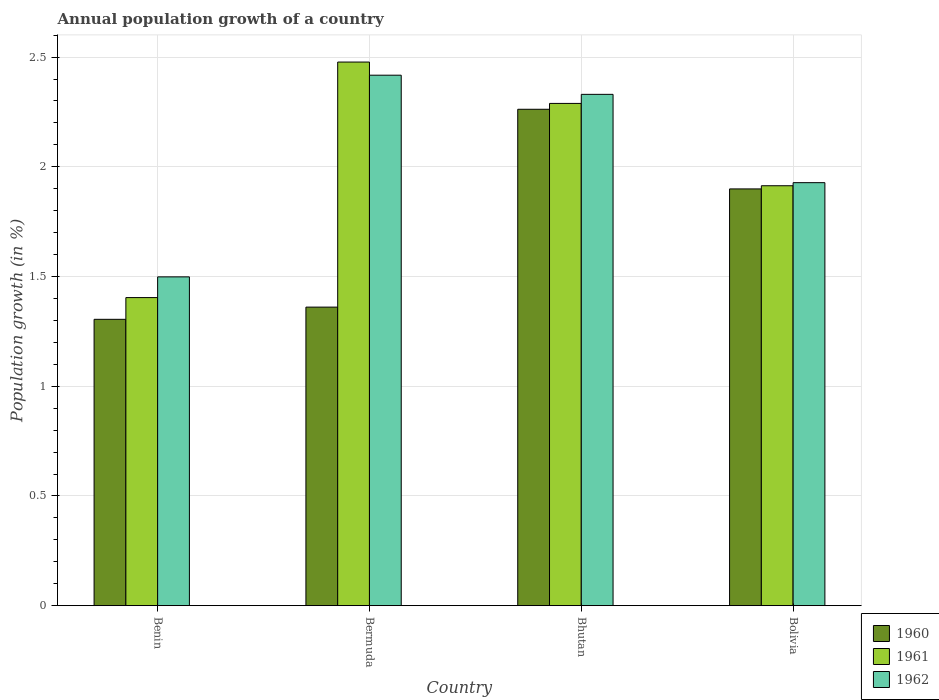How many bars are there on the 1st tick from the right?
Your answer should be compact. 3. What is the label of the 2nd group of bars from the left?
Ensure brevity in your answer.  Bermuda. What is the annual population growth in 1962 in Bermuda?
Offer a very short reply. 2.42. Across all countries, what is the maximum annual population growth in 1960?
Provide a short and direct response. 2.26. Across all countries, what is the minimum annual population growth in 1961?
Your response must be concise. 1.4. In which country was the annual population growth in 1960 maximum?
Make the answer very short. Bhutan. In which country was the annual population growth in 1962 minimum?
Your response must be concise. Benin. What is the total annual population growth in 1960 in the graph?
Your response must be concise. 6.83. What is the difference between the annual population growth in 1961 in Bhutan and that in Bolivia?
Your answer should be compact. 0.38. What is the difference between the annual population growth in 1960 in Bolivia and the annual population growth in 1962 in Benin?
Give a very brief answer. 0.4. What is the average annual population growth in 1960 per country?
Ensure brevity in your answer.  1.71. What is the difference between the annual population growth of/in 1961 and annual population growth of/in 1962 in Benin?
Provide a succinct answer. -0.09. In how many countries, is the annual population growth in 1961 greater than 0.30000000000000004 %?
Ensure brevity in your answer.  4. What is the ratio of the annual population growth in 1960 in Benin to that in Bhutan?
Offer a terse response. 0.58. Is the difference between the annual population growth in 1961 in Bhutan and Bolivia greater than the difference between the annual population growth in 1962 in Bhutan and Bolivia?
Provide a short and direct response. No. What is the difference between the highest and the second highest annual population growth in 1960?
Make the answer very short. -0.36. What is the difference between the highest and the lowest annual population growth in 1961?
Provide a succinct answer. 1.07. In how many countries, is the annual population growth in 1962 greater than the average annual population growth in 1962 taken over all countries?
Provide a short and direct response. 2. Is the sum of the annual population growth in 1962 in Benin and Bermuda greater than the maximum annual population growth in 1961 across all countries?
Keep it short and to the point. Yes. What does the 3rd bar from the left in Bhutan represents?
Provide a short and direct response. 1962. Is it the case that in every country, the sum of the annual population growth in 1961 and annual population growth in 1960 is greater than the annual population growth in 1962?
Keep it short and to the point. Yes. How many bars are there?
Your answer should be very brief. 12. Are the values on the major ticks of Y-axis written in scientific E-notation?
Give a very brief answer. No. Does the graph contain any zero values?
Your response must be concise. No. Does the graph contain grids?
Give a very brief answer. Yes. Where does the legend appear in the graph?
Offer a very short reply. Bottom right. How are the legend labels stacked?
Your answer should be very brief. Vertical. What is the title of the graph?
Give a very brief answer. Annual population growth of a country. What is the label or title of the X-axis?
Your response must be concise. Country. What is the label or title of the Y-axis?
Provide a succinct answer. Population growth (in %). What is the Population growth (in %) of 1960 in Benin?
Give a very brief answer. 1.3. What is the Population growth (in %) in 1961 in Benin?
Your answer should be compact. 1.4. What is the Population growth (in %) in 1962 in Benin?
Provide a short and direct response. 1.5. What is the Population growth (in %) in 1960 in Bermuda?
Ensure brevity in your answer.  1.36. What is the Population growth (in %) in 1961 in Bermuda?
Your answer should be compact. 2.48. What is the Population growth (in %) of 1962 in Bermuda?
Make the answer very short. 2.42. What is the Population growth (in %) of 1960 in Bhutan?
Offer a terse response. 2.26. What is the Population growth (in %) in 1961 in Bhutan?
Make the answer very short. 2.29. What is the Population growth (in %) of 1962 in Bhutan?
Make the answer very short. 2.33. What is the Population growth (in %) in 1960 in Bolivia?
Your answer should be compact. 1.9. What is the Population growth (in %) in 1961 in Bolivia?
Provide a short and direct response. 1.91. What is the Population growth (in %) of 1962 in Bolivia?
Keep it short and to the point. 1.93. Across all countries, what is the maximum Population growth (in %) in 1960?
Ensure brevity in your answer.  2.26. Across all countries, what is the maximum Population growth (in %) of 1961?
Make the answer very short. 2.48. Across all countries, what is the maximum Population growth (in %) of 1962?
Provide a succinct answer. 2.42. Across all countries, what is the minimum Population growth (in %) of 1960?
Your answer should be very brief. 1.3. Across all countries, what is the minimum Population growth (in %) in 1961?
Give a very brief answer. 1.4. Across all countries, what is the minimum Population growth (in %) of 1962?
Ensure brevity in your answer.  1.5. What is the total Population growth (in %) of 1960 in the graph?
Give a very brief answer. 6.83. What is the total Population growth (in %) of 1961 in the graph?
Provide a short and direct response. 8.08. What is the total Population growth (in %) of 1962 in the graph?
Your response must be concise. 8.17. What is the difference between the Population growth (in %) in 1960 in Benin and that in Bermuda?
Make the answer very short. -0.06. What is the difference between the Population growth (in %) of 1961 in Benin and that in Bermuda?
Provide a short and direct response. -1.07. What is the difference between the Population growth (in %) of 1962 in Benin and that in Bermuda?
Offer a terse response. -0.92. What is the difference between the Population growth (in %) of 1960 in Benin and that in Bhutan?
Your answer should be very brief. -0.96. What is the difference between the Population growth (in %) of 1961 in Benin and that in Bhutan?
Give a very brief answer. -0.89. What is the difference between the Population growth (in %) of 1962 in Benin and that in Bhutan?
Your answer should be compact. -0.83. What is the difference between the Population growth (in %) of 1960 in Benin and that in Bolivia?
Provide a succinct answer. -0.59. What is the difference between the Population growth (in %) in 1961 in Benin and that in Bolivia?
Keep it short and to the point. -0.51. What is the difference between the Population growth (in %) in 1962 in Benin and that in Bolivia?
Offer a very short reply. -0.43. What is the difference between the Population growth (in %) of 1960 in Bermuda and that in Bhutan?
Ensure brevity in your answer.  -0.9. What is the difference between the Population growth (in %) in 1961 in Bermuda and that in Bhutan?
Provide a succinct answer. 0.19. What is the difference between the Population growth (in %) in 1962 in Bermuda and that in Bhutan?
Offer a terse response. 0.09. What is the difference between the Population growth (in %) of 1960 in Bermuda and that in Bolivia?
Your answer should be compact. -0.54. What is the difference between the Population growth (in %) of 1961 in Bermuda and that in Bolivia?
Give a very brief answer. 0.56. What is the difference between the Population growth (in %) in 1962 in Bermuda and that in Bolivia?
Offer a terse response. 0.49. What is the difference between the Population growth (in %) in 1960 in Bhutan and that in Bolivia?
Offer a very short reply. 0.36. What is the difference between the Population growth (in %) of 1961 in Bhutan and that in Bolivia?
Make the answer very short. 0.38. What is the difference between the Population growth (in %) in 1962 in Bhutan and that in Bolivia?
Your answer should be compact. 0.4. What is the difference between the Population growth (in %) in 1960 in Benin and the Population growth (in %) in 1961 in Bermuda?
Your answer should be very brief. -1.17. What is the difference between the Population growth (in %) of 1960 in Benin and the Population growth (in %) of 1962 in Bermuda?
Your response must be concise. -1.11. What is the difference between the Population growth (in %) in 1961 in Benin and the Population growth (in %) in 1962 in Bermuda?
Your answer should be very brief. -1.01. What is the difference between the Population growth (in %) of 1960 in Benin and the Population growth (in %) of 1961 in Bhutan?
Your answer should be compact. -0.98. What is the difference between the Population growth (in %) of 1960 in Benin and the Population growth (in %) of 1962 in Bhutan?
Your answer should be compact. -1.03. What is the difference between the Population growth (in %) in 1961 in Benin and the Population growth (in %) in 1962 in Bhutan?
Ensure brevity in your answer.  -0.93. What is the difference between the Population growth (in %) of 1960 in Benin and the Population growth (in %) of 1961 in Bolivia?
Your answer should be compact. -0.61. What is the difference between the Population growth (in %) of 1960 in Benin and the Population growth (in %) of 1962 in Bolivia?
Ensure brevity in your answer.  -0.62. What is the difference between the Population growth (in %) of 1961 in Benin and the Population growth (in %) of 1962 in Bolivia?
Your answer should be compact. -0.52. What is the difference between the Population growth (in %) in 1960 in Bermuda and the Population growth (in %) in 1961 in Bhutan?
Offer a very short reply. -0.93. What is the difference between the Population growth (in %) of 1960 in Bermuda and the Population growth (in %) of 1962 in Bhutan?
Make the answer very short. -0.97. What is the difference between the Population growth (in %) in 1961 in Bermuda and the Population growth (in %) in 1962 in Bhutan?
Your response must be concise. 0.15. What is the difference between the Population growth (in %) in 1960 in Bermuda and the Population growth (in %) in 1961 in Bolivia?
Make the answer very short. -0.55. What is the difference between the Population growth (in %) of 1960 in Bermuda and the Population growth (in %) of 1962 in Bolivia?
Offer a very short reply. -0.57. What is the difference between the Population growth (in %) in 1961 in Bermuda and the Population growth (in %) in 1962 in Bolivia?
Provide a succinct answer. 0.55. What is the difference between the Population growth (in %) of 1960 in Bhutan and the Population growth (in %) of 1961 in Bolivia?
Your answer should be very brief. 0.35. What is the difference between the Population growth (in %) in 1960 in Bhutan and the Population growth (in %) in 1962 in Bolivia?
Offer a very short reply. 0.33. What is the difference between the Population growth (in %) of 1961 in Bhutan and the Population growth (in %) of 1962 in Bolivia?
Your answer should be compact. 0.36. What is the average Population growth (in %) in 1960 per country?
Provide a succinct answer. 1.71. What is the average Population growth (in %) of 1961 per country?
Your answer should be very brief. 2.02. What is the average Population growth (in %) of 1962 per country?
Make the answer very short. 2.04. What is the difference between the Population growth (in %) of 1960 and Population growth (in %) of 1961 in Benin?
Your response must be concise. -0.1. What is the difference between the Population growth (in %) of 1960 and Population growth (in %) of 1962 in Benin?
Provide a succinct answer. -0.19. What is the difference between the Population growth (in %) in 1961 and Population growth (in %) in 1962 in Benin?
Your answer should be compact. -0.09. What is the difference between the Population growth (in %) in 1960 and Population growth (in %) in 1961 in Bermuda?
Provide a short and direct response. -1.12. What is the difference between the Population growth (in %) in 1960 and Population growth (in %) in 1962 in Bermuda?
Keep it short and to the point. -1.06. What is the difference between the Population growth (in %) of 1961 and Population growth (in %) of 1962 in Bermuda?
Your response must be concise. 0.06. What is the difference between the Population growth (in %) of 1960 and Population growth (in %) of 1961 in Bhutan?
Ensure brevity in your answer.  -0.03. What is the difference between the Population growth (in %) in 1960 and Population growth (in %) in 1962 in Bhutan?
Make the answer very short. -0.07. What is the difference between the Population growth (in %) in 1961 and Population growth (in %) in 1962 in Bhutan?
Make the answer very short. -0.04. What is the difference between the Population growth (in %) of 1960 and Population growth (in %) of 1961 in Bolivia?
Keep it short and to the point. -0.01. What is the difference between the Population growth (in %) of 1960 and Population growth (in %) of 1962 in Bolivia?
Keep it short and to the point. -0.03. What is the difference between the Population growth (in %) of 1961 and Population growth (in %) of 1962 in Bolivia?
Give a very brief answer. -0.01. What is the ratio of the Population growth (in %) of 1960 in Benin to that in Bermuda?
Keep it short and to the point. 0.96. What is the ratio of the Population growth (in %) in 1961 in Benin to that in Bermuda?
Provide a short and direct response. 0.57. What is the ratio of the Population growth (in %) of 1962 in Benin to that in Bermuda?
Provide a short and direct response. 0.62. What is the ratio of the Population growth (in %) of 1960 in Benin to that in Bhutan?
Your response must be concise. 0.58. What is the ratio of the Population growth (in %) of 1961 in Benin to that in Bhutan?
Your answer should be compact. 0.61. What is the ratio of the Population growth (in %) of 1962 in Benin to that in Bhutan?
Your answer should be compact. 0.64. What is the ratio of the Population growth (in %) of 1960 in Benin to that in Bolivia?
Keep it short and to the point. 0.69. What is the ratio of the Population growth (in %) in 1961 in Benin to that in Bolivia?
Keep it short and to the point. 0.73. What is the ratio of the Population growth (in %) of 1962 in Benin to that in Bolivia?
Make the answer very short. 0.78. What is the ratio of the Population growth (in %) in 1960 in Bermuda to that in Bhutan?
Your answer should be compact. 0.6. What is the ratio of the Population growth (in %) in 1961 in Bermuda to that in Bhutan?
Offer a terse response. 1.08. What is the ratio of the Population growth (in %) in 1962 in Bermuda to that in Bhutan?
Your answer should be compact. 1.04. What is the ratio of the Population growth (in %) of 1960 in Bermuda to that in Bolivia?
Provide a short and direct response. 0.72. What is the ratio of the Population growth (in %) of 1961 in Bermuda to that in Bolivia?
Give a very brief answer. 1.29. What is the ratio of the Population growth (in %) in 1962 in Bermuda to that in Bolivia?
Offer a very short reply. 1.25. What is the ratio of the Population growth (in %) in 1960 in Bhutan to that in Bolivia?
Your answer should be compact. 1.19. What is the ratio of the Population growth (in %) of 1961 in Bhutan to that in Bolivia?
Keep it short and to the point. 1.2. What is the ratio of the Population growth (in %) in 1962 in Bhutan to that in Bolivia?
Give a very brief answer. 1.21. What is the difference between the highest and the second highest Population growth (in %) of 1960?
Your answer should be very brief. 0.36. What is the difference between the highest and the second highest Population growth (in %) of 1961?
Your response must be concise. 0.19. What is the difference between the highest and the second highest Population growth (in %) of 1962?
Provide a short and direct response. 0.09. What is the difference between the highest and the lowest Population growth (in %) of 1960?
Offer a terse response. 0.96. What is the difference between the highest and the lowest Population growth (in %) in 1961?
Your answer should be very brief. 1.07. What is the difference between the highest and the lowest Population growth (in %) in 1962?
Keep it short and to the point. 0.92. 